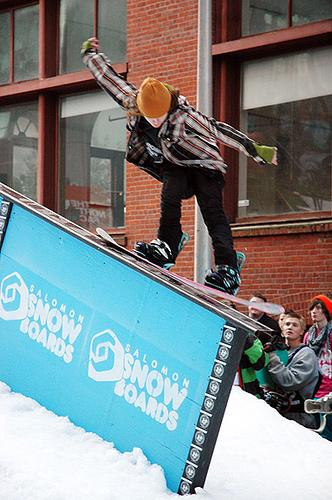What is this wall used for? snowboarding 